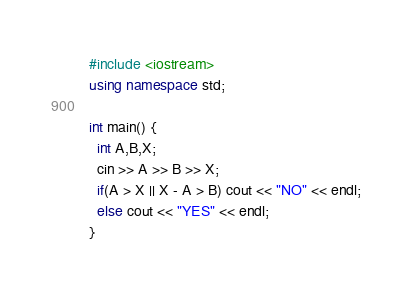<code> <loc_0><loc_0><loc_500><loc_500><_C++_>#include <iostream>
using namespace std;

int main() {
  int A,B,X;
  cin >> A >> B >> X;
  if(A > X || X - A > B) cout << "NO" << endl;
  else cout << "YES" << endl;
}</code> 